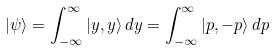<formula> <loc_0><loc_0><loc_500><loc_500>| \psi \rangle = \int _ { - \infty } ^ { \infty } | y , y \rangle \, d y = \int _ { - \infty } ^ { \infty } | p , - p \rangle \, d p</formula> 